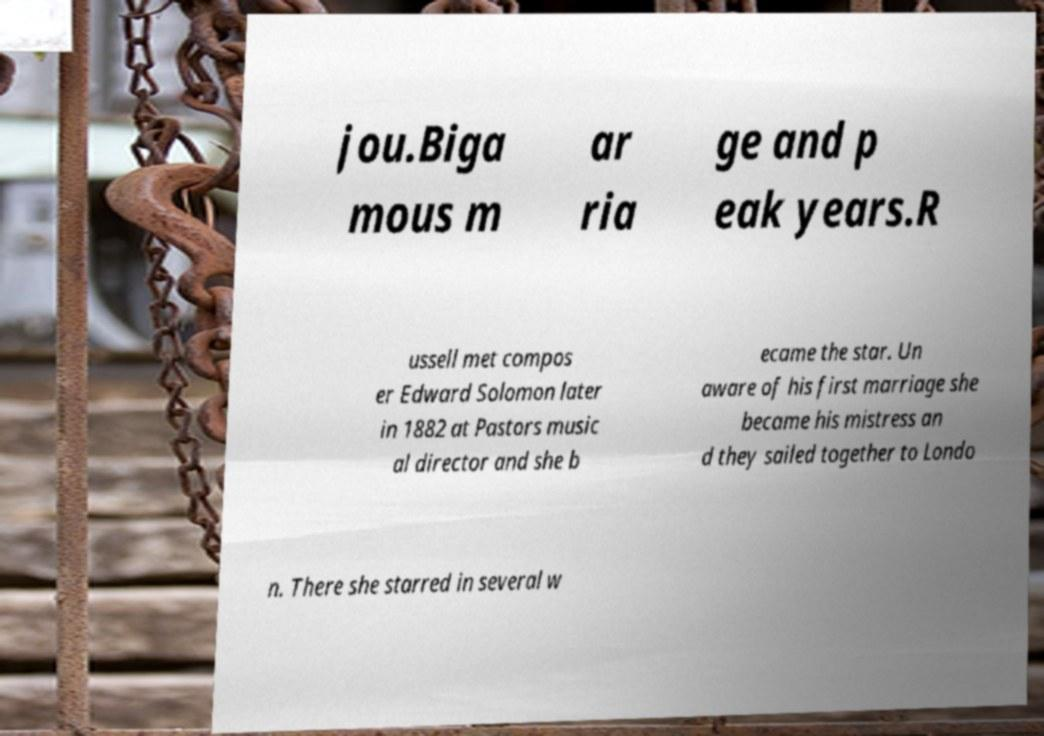Could you extract and type out the text from this image? jou.Biga mous m ar ria ge and p eak years.R ussell met compos er Edward Solomon later in 1882 at Pastors music al director and she b ecame the star. Un aware of his first marriage she became his mistress an d they sailed together to Londo n. There she starred in several w 